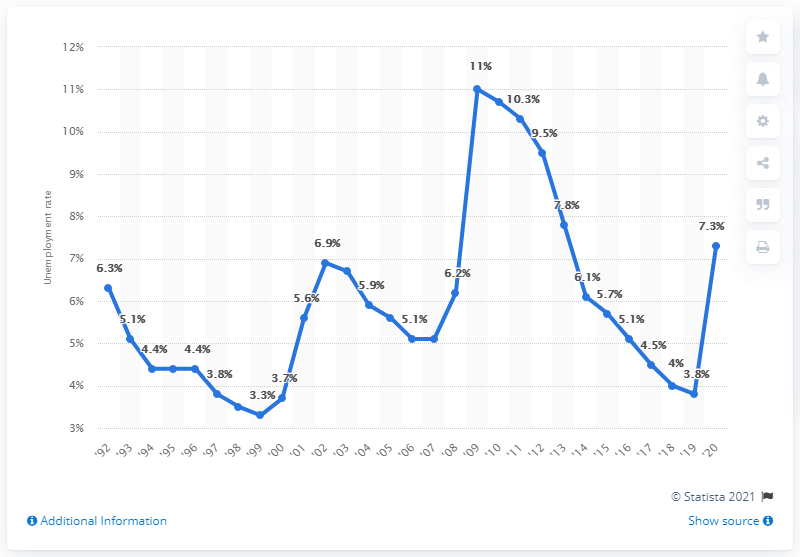Identify some key points in this picture. In 2009, the unemployment rate in North Carolina was 3.8%. In 2009, the highest unemployment rate in North Carolina was 11%. In 2020, the unemployment rate in North Carolina was 7.3%. 